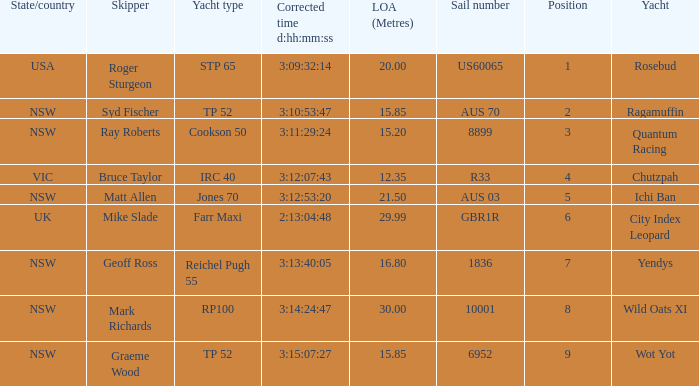Would you be able to parse every entry in this table? {'header': ['State/country', 'Skipper', 'Yacht type', 'Corrected time d:hh:mm:ss', 'LOA (Metres)', 'Sail number', 'Position', 'Yacht'], 'rows': [['USA', 'Roger Sturgeon', 'STP 65', '3:09:32:14', '20.00', 'US60065', '1', 'Rosebud'], ['NSW', 'Syd Fischer', 'TP 52', '3:10:53:47', '15.85', 'AUS 70', '2', 'Ragamuffin'], ['NSW', 'Ray Roberts', 'Cookson 50', '3:11:29:24', '15.20', '8899', '3', 'Quantum Racing'], ['VIC', 'Bruce Taylor', 'IRC 40', '3:12:07:43', '12.35', 'R33', '4', 'Chutzpah'], ['NSW', 'Matt Allen', 'Jones 70', '3:12:53:20', '21.50', 'AUS 03', '5', 'Ichi Ban'], ['UK', 'Mike Slade', 'Farr Maxi', '2:13:04:48', '29.99', 'GBR1R', '6', 'City Index Leopard'], ['NSW', 'Geoff Ross', 'Reichel Pugh 55', '3:13:40:05', '16.80', '1836', '7', 'Yendys'], ['NSW', 'Mark Richards', 'RP100', '3:14:24:47', '30.00', '10001', '8', 'Wild Oats XI'], ['NSW', 'Graeme Wood', 'TP 52', '3:15:07:27', '15.85', '6952', '9', 'Wot Yot']]} How many yachts had a position of 3? 1.0. 